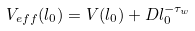<formula> <loc_0><loc_0><loc_500><loc_500>V _ { e f f } ( l _ { 0 } ) = V ( l _ { 0 } ) + D l _ { 0 } ^ { - \tau _ { w } }</formula> 